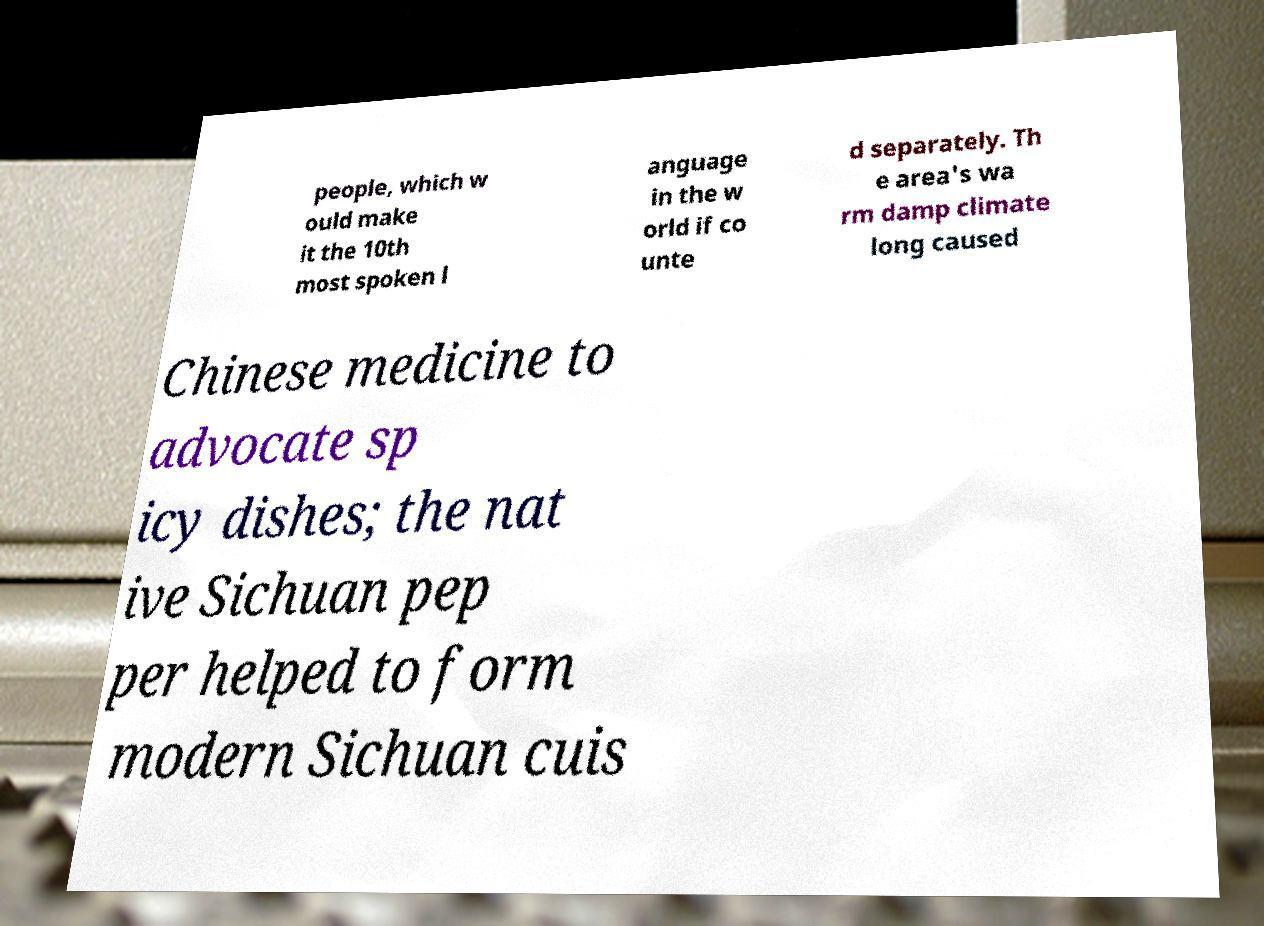I need the written content from this picture converted into text. Can you do that? people, which w ould make it the 10th most spoken l anguage in the w orld if co unte d separately. Th e area's wa rm damp climate long caused Chinese medicine to advocate sp icy dishes; the nat ive Sichuan pep per helped to form modern Sichuan cuis 